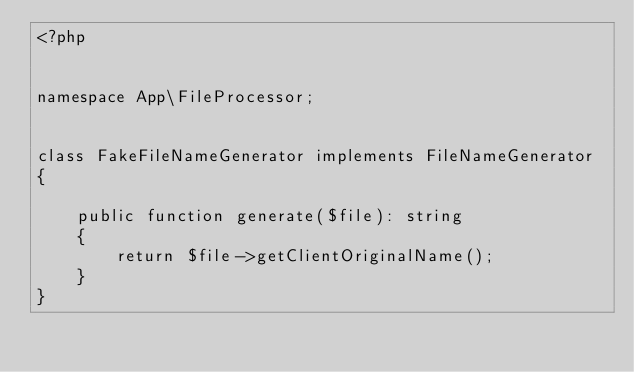Convert code to text. <code><loc_0><loc_0><loc_500><loc_500><_PHP_><?php


namespace App\FileProcessor;


class FakeFileNameGenerator implements FileNameGenerator
{

    public function generate($file): string
    {
        return $file->getClientOriginalName();
    }
}
</code> 